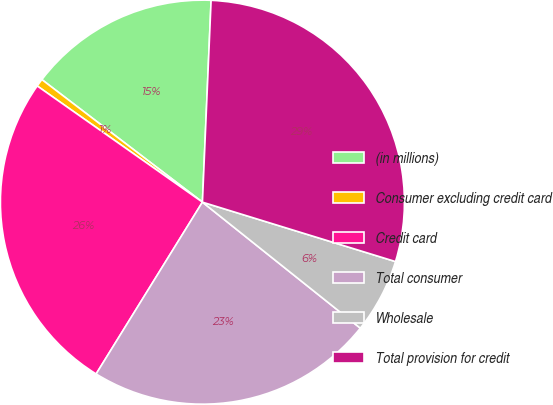Convert chart to OTSL. <chart><loc_0><loc_0><loc_500><loc_500><pie_chart><fcel>(in millions)<fcel>Consumer excluding credit card<fcel>Credit card<fcel>Total consumer<fcel>Wholesale<fcel>Total provision for credit<nl><fcel>15.31%<fcel>0.62%<fcel>25.94%<fcel>23.1%<fcel>5.97%<fcel>29.07%<nl></chart> 